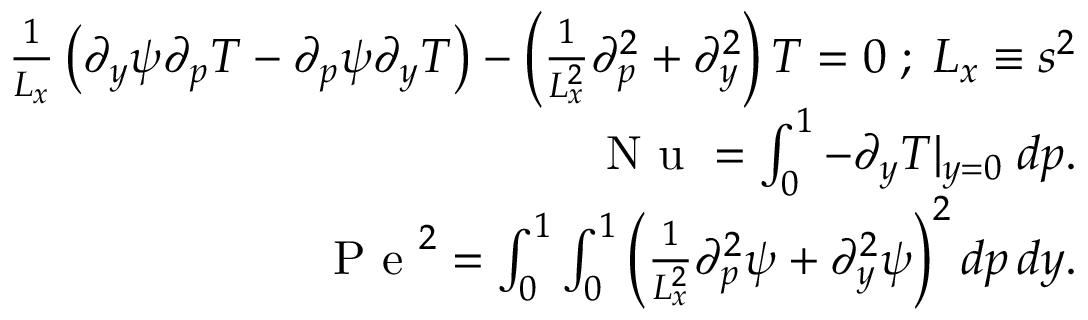Convert formula to latex. <formula><loc_0><loc_0><loc_500><loc_500>\begin{array} { r } { \frac { 1 } { L _ { x } } \left ( \partial _ { y } \psi \partial _ { p } T - \partial _ { p } \psi \partial _ { y } T \right ) - \left ( \frac { 1 } { L _ { x } ^ { 2 } } \partial _ { p } ^ { 2 } + \partial _ { y } ^ { 2 } \right ) T = 0 \, ; \, L _ { x } \equiv s ^ { 2 } } \\ { N u = \int _ { 0 } ^ { 1 } - \partial _ { y } T | _ { y = 0 } \, d p . } \\ { P e ^ { 2 } = \int _ { 0 } ^ { 1 } \int _ { 0 } ^ { 1 } \left ( \frac { 1 } { L _ { x } ^ { 2 } } \partial _ { p } ^ { 2 } \psi + \partial _ { y } ^ { 2 } \psi \right ) ^ { 2 } d p \, d y . } \end{array}</formula> 